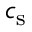<formula> <loc_0><loc_0><loc_500><loc_500>c _ { s }</formula> 